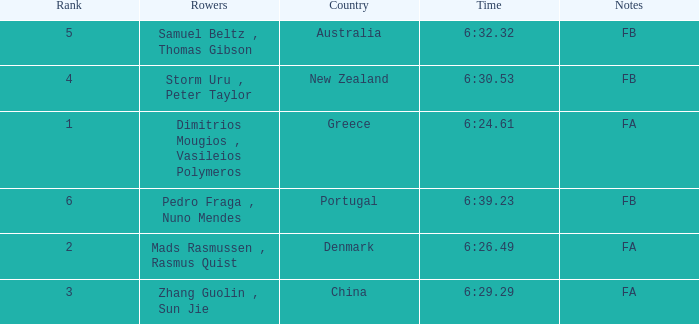What country has a rank smaller than 6, a time of 6:32.32 and notes of FB? Australia. 